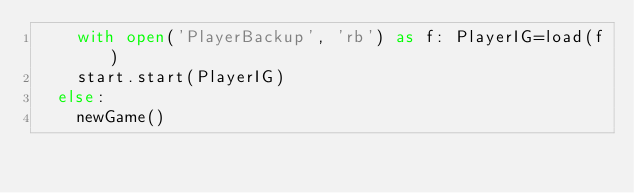Convert code to text. <code><loc_0><loc_0><loc_500><loc_500><_Python_>    with open('PlayerBackup', 'rb') as f: PlayerIG=load(f)
    start.start(PlayerIG)
  else:
    newGame()
</code> 